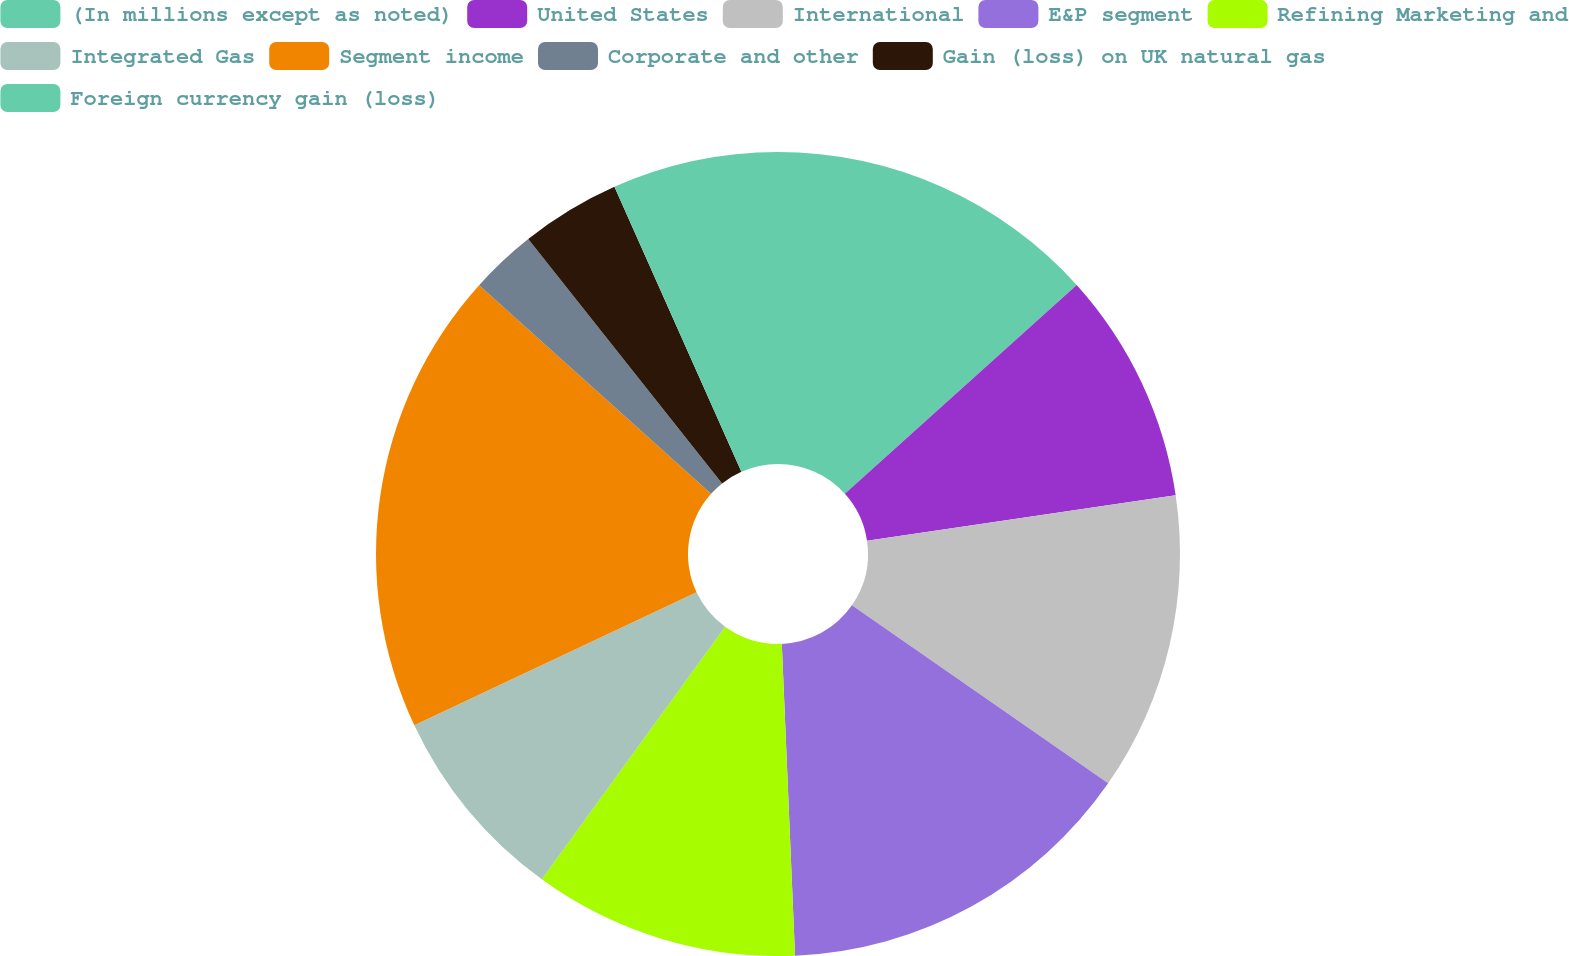Convert chart to OTSL. <chart><loc_0><loc_0><loc_500><loc_500><pie_chart><fcel>(In millions except as noted)<fcel>United States<fcel>International<fcel>E&P segment<fcel>Refining Marketing and<fcel>Integrated Gas<fcel>Segment income<fcel>Corporate and other<fcel>Gain (loss) on UK natural gas<fcel>Foreign currency gain (loss)<nl><fcel>13.33%<fcel>9.33%<fcel>12.0%<fcel>14.66%<fcel>10.67%<fcel>8.0%<fcel>18.66%<fcel>2.67%<fcel>4.0%<fcel>6.67%<nl></chart> 